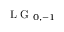<formula> <loc_0><loc_0><loc_500><loc_500>L G _ { 0 , - 1 }</formula> 